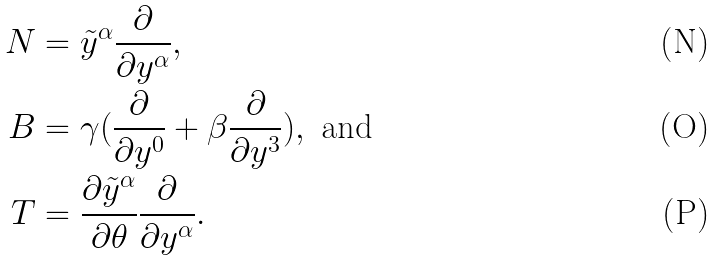Convert formula to latex. <formula><loc_0><loc_0><loc_500><loc_500>N & = \tilde { y } ^ { \alpha } \frac { \partial } { \partial y ^ { \alpha } } , \\ B & = \gamma ( \frac { \partial } { \partial y ^ { 0 } } + \beta \frac { \partial } { \partial y ^ { 3 } } ) , \text { and} \\ T & = \frac { \partial \tilde { y } ^ { \alpha } } { \partial \theta } \frac { \partial } { \partial y ^ { \alpha } } .</formula> 